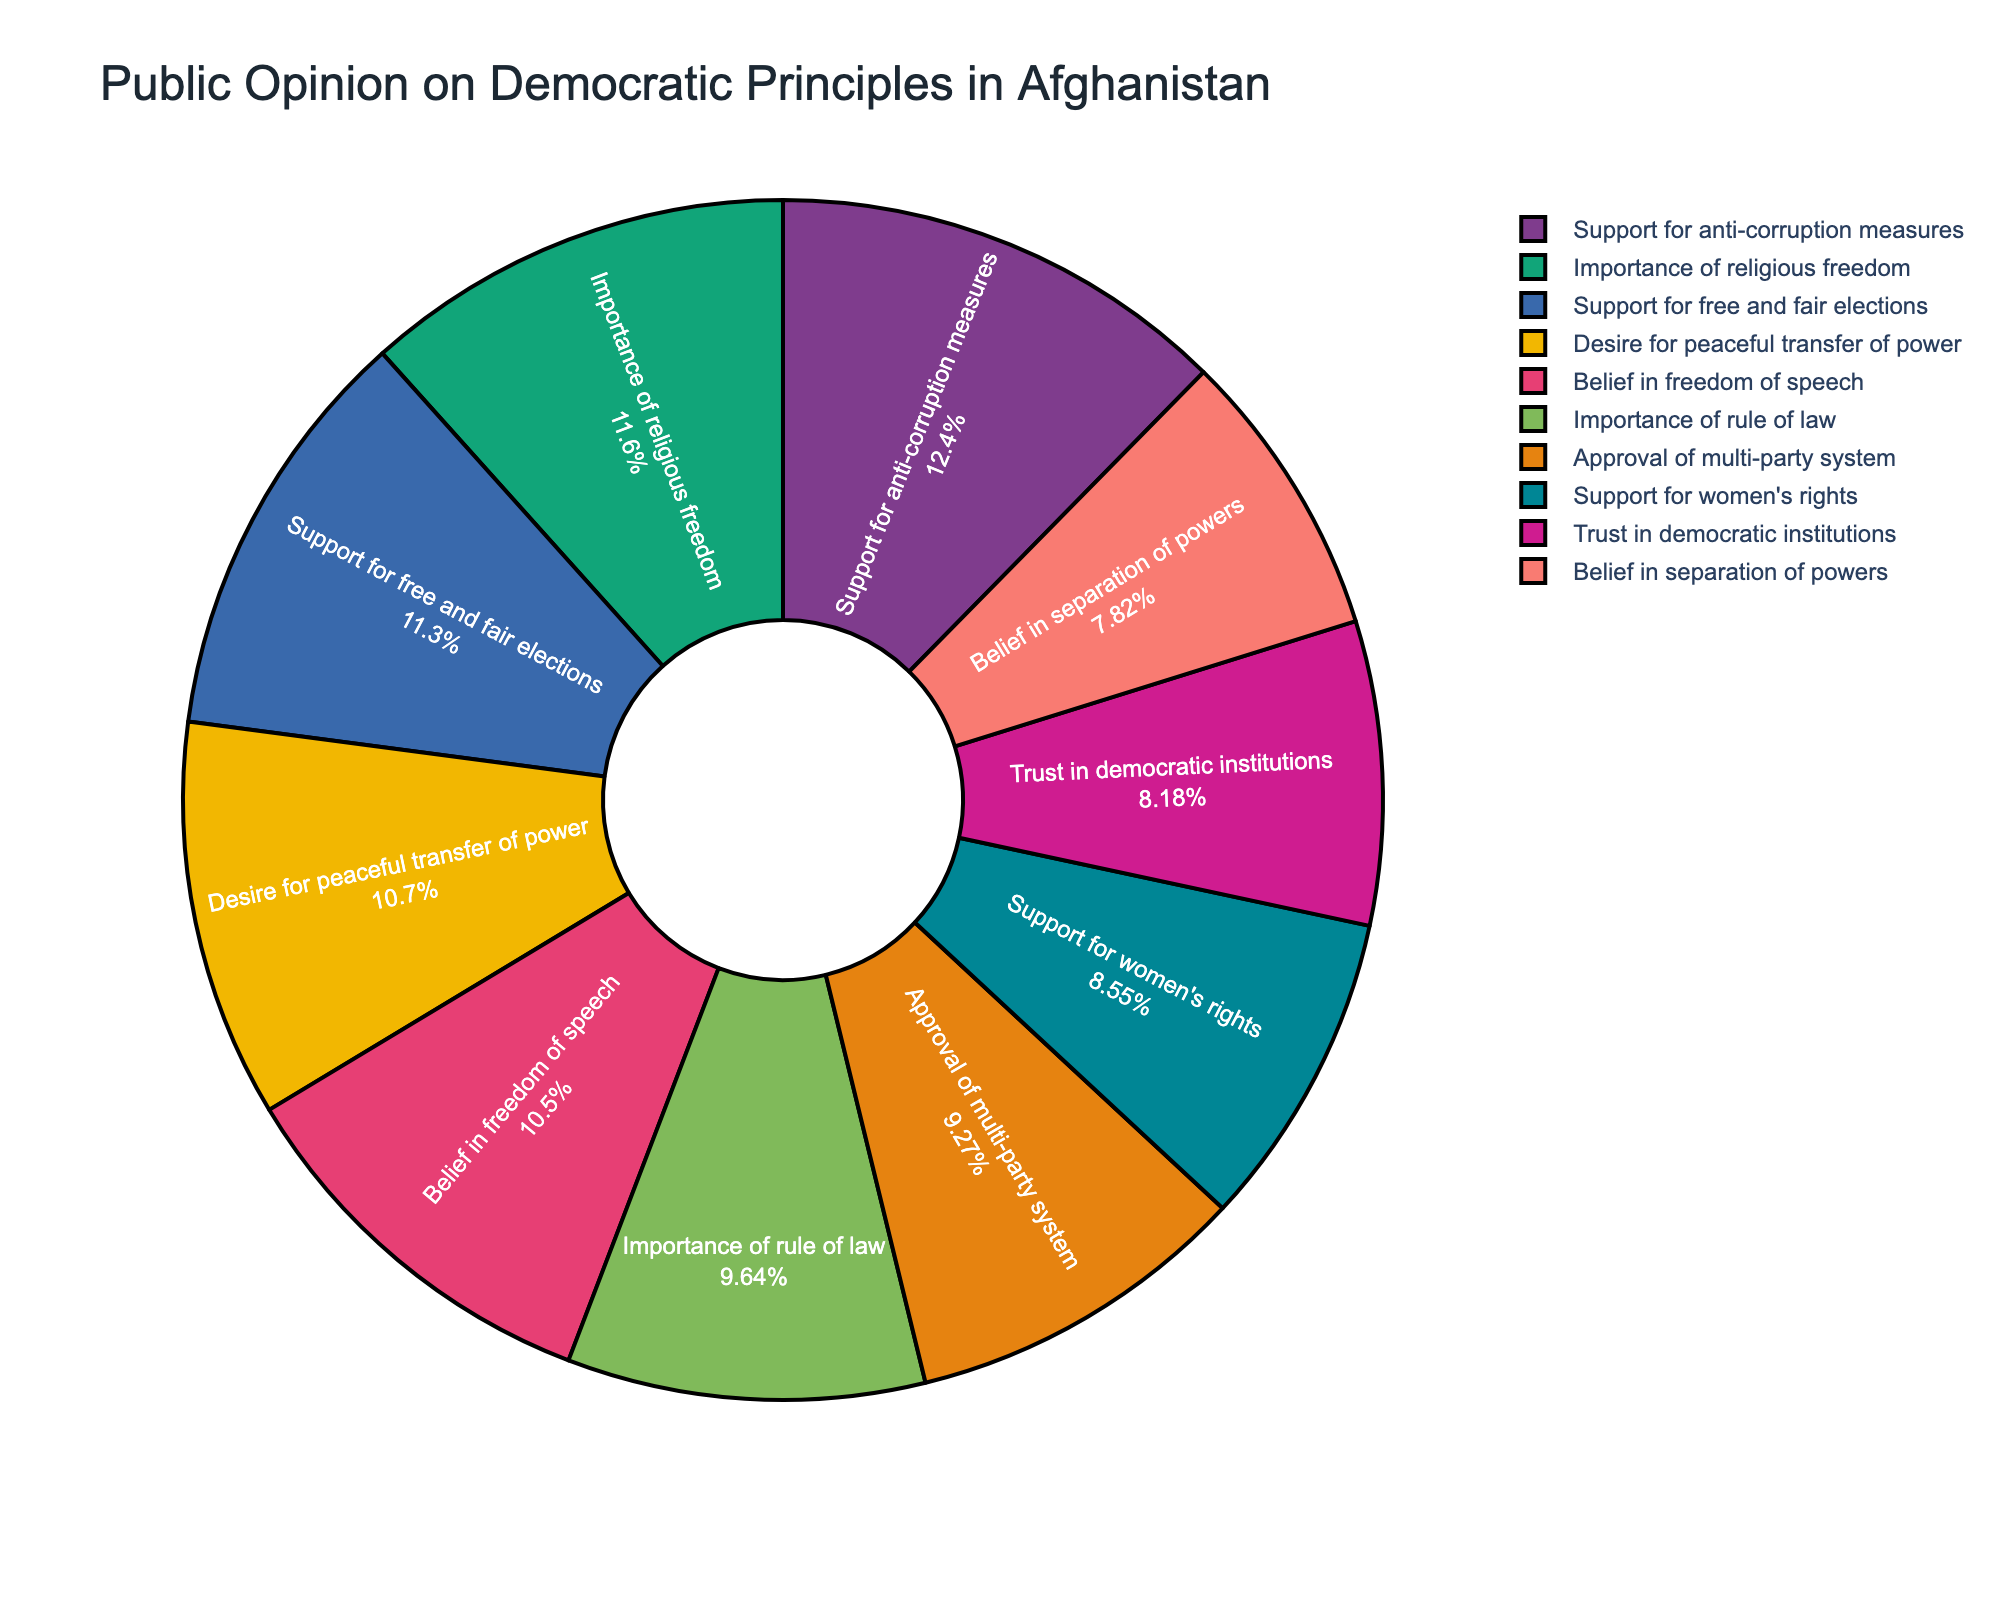Which category has the highest public support in the figure? The category with the highest percentage is the most supported. "Support for anti-corruption measures" shows the highest percentage at 68%.
Answer: Support for anti-corruption measures Which two categories are the closest in their percentages? To find the closest percentages, compare the differences between each pair. "Approval of multi-party system" and "Importance of rule of law" are very close, 51% and 53% respectively, making the difference 2%.
Answer: Approval of multi-party system and Importance of rule of law Identify the categories related to freedoms and their combined percentage. Look for categories mentioning "freedom" and add their percentages: "Belief in freedom of speech" (58%) and "Importance of religious freedom" (64%). Combined percentage = 58 + 64 = 122%.
Answer: 122% What is the difference in percentage between the "Support for free and fair elections" and "Trust in democratic institutions"? Subtract the percentage of "Trust in democratic institutions" from "Support for free and fair elections": Difference = 62 - 45 = 17%.
Answer: 17% Which category has the least public support? The category with the lowest percentage has the least support. "Belief in separation of powers" has the lowest percentage at 43%.
Answer: Belief in separation of powers How many categories have over 50% support? Count the categories with percentages greater than 50%. There are six: "Support for free and fair elections" (62%), "Belief in freedom of speech" (58%), "Importance of rule of law" (53%), "Desire for peaceful transfer of power" (59%), "Importance of religious freedom" (64%), and "Support for anti-corruption measures" (68%).
Answer: 6 What is the sum of support percentages for categories explicitly related to governance structures? Identify categories discussing governance structures and sum their percentages: "Trust in democratic institutions" (45%), "Desire for peaceful transfer of power" (59%), "Approval of multi-party system" (51%), "Belief in separation of powers" (43%). Sum = 45 + 59 + 51 + 43 = 198%.
Answer: 198% Which democratic principle is more supported, "Support for women's rights" or "Importance of rule of law"? Compare the percentage of "Support for women's rights" (47%) with "Importance of rule of law" (53%). The latter has a higher percentage.
Answer: Importance of rule of law What is the average percentage of support across all categories? Sum all percentages and divide by the number of categories: (62 + 58 + 45 + 53 + 47 + 59 + 51 + 64 + 68 + 43) / 10 = 550 / 10 = 55%.
Answer: 55% 